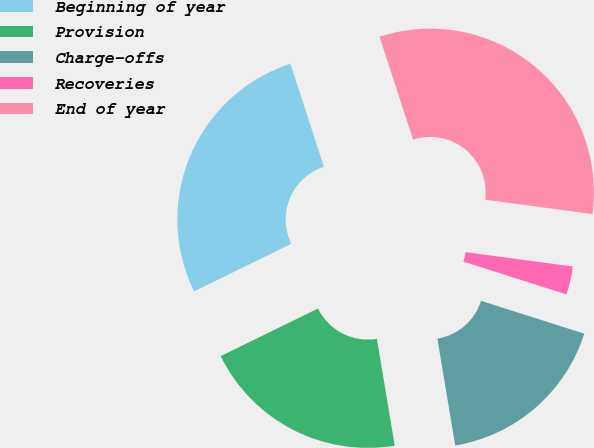Convert chart. <chart><loc_0><loc_0><loc_500><loc_500><pie_chart><fcel>Beginning of year<fcel>Provision<fcel>Charge-offs<fcel>Recoveries<fcel>End of year<nl><fcel>27.23%<fcel>20.39%<fcel>17.46%<fcel>2.79%<fcel>32.12%<nl></chart> 